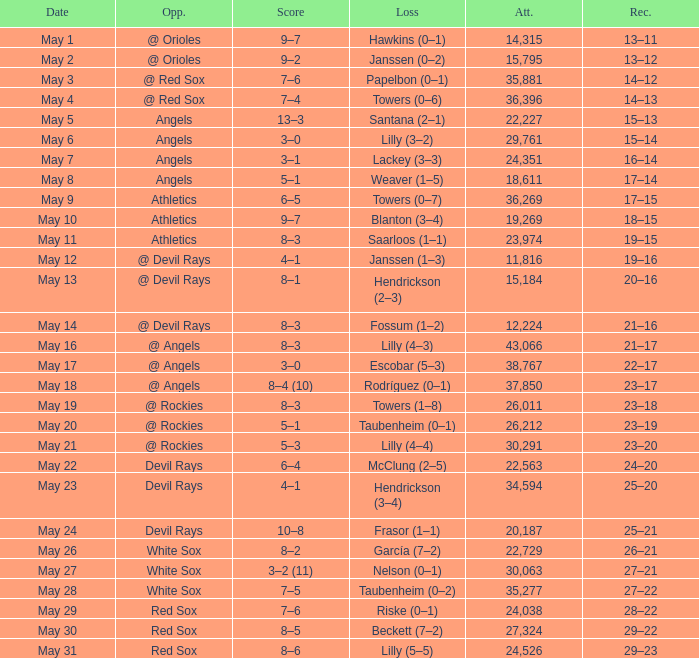What was the average attendance for games with a loss of papelbon (0–1)? 35881.0. 